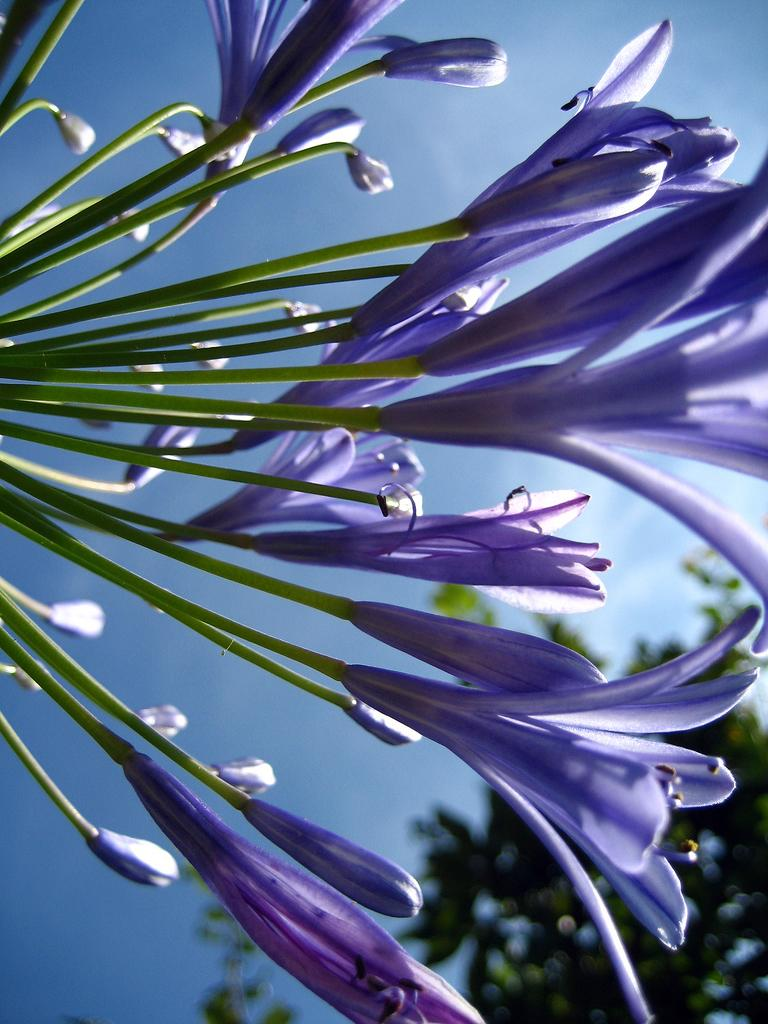What type of plants can be seen in the image? There are flowers in the image. What part of the flowers is visible in the image? There are stems in the image. What can be seen in the background of the image? There is a tree and the sky visible in the background of the image. How many books are stacked on the wall in the image? There are no books or walls present in the image; it features flowers, stems, a tree, and the sky. 